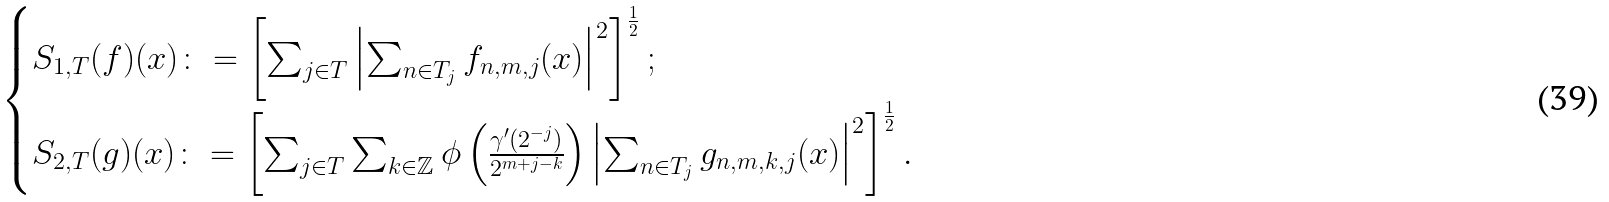Convert formula to latex. <formula><loc_0><loc_0><loc_500><loc_500>\begin{cases} S _ { 1 , T } ( f ) ( x ) \colon = \left [ \sum _ { j \in T } \left | \sum _ { n \in T _ { j } } f _ { n , m , j } ( x ) \right | ^ { 2 } \right ] ^ { \frac { 1 } { 2 } } ; \\ S _ { 2 , T } ( g ) ( x ) \colon = \left [ \sum _ { j \in T } \sum _ { k \in \mathbb { Z } } \phi \left ( \frac { \gamma ^ { \prime } ( 2 ^ { - j } ) } { 2 ^ { m + j - k } } \right ) \left | \sum _ { n \in T _ { j } } g _ { n , m , k , j } ( x ) \right | ^ { 2 } \right ] ^ { \frac { 1 } { 2 } } . \end{cases}</formula> 